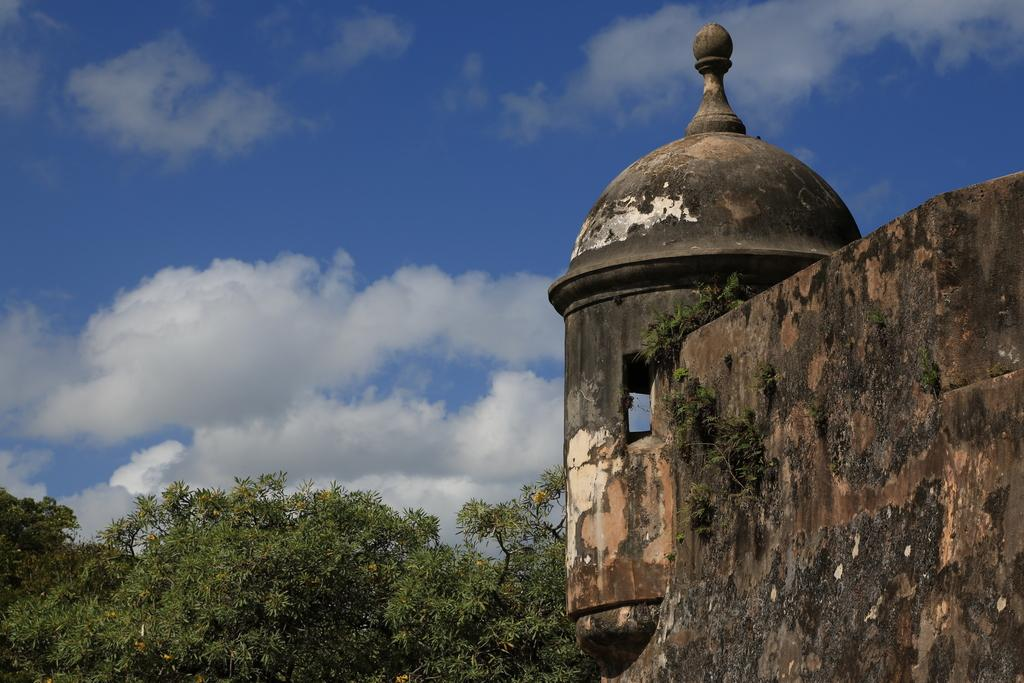What type of structure is present in the image? There is a building in the image. What can be seen near the building? There are many trees near the building. What is visible in the background of the image? There are clouds and a blue sky visible in the background of the image. How many chairs are there in the image? There is no mention of chairs in the image, so we cannot determine the number of chairs. 